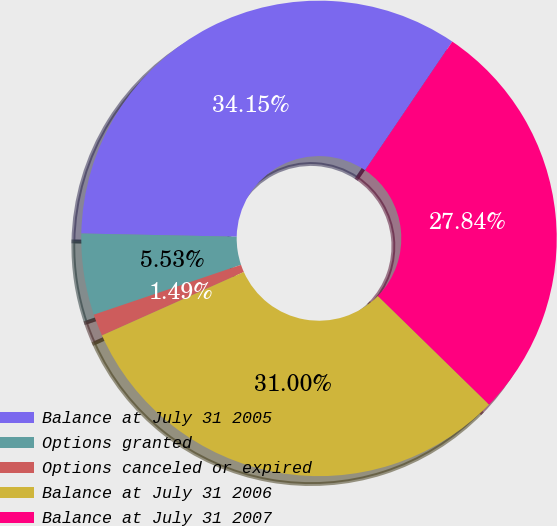Convert chart. <chart><loc_0><loc_0><loc_500><loc_500><pie_chart><fcel>Balance at July 31 2005<fcel>Options granted<fcel>Options canceled or expired<fcel>Balance at July 31 2006<fcel>Balance at July 31 2007<nl><fcel>34.15%<fcel>5.53%<fcel>1.49%<fcel>31.0%<fcel>27.84%<nl></chart> 